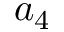<formula> <loc_0><loc_0><loc_500><loc_500>a _ { 4 }</formula> 